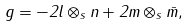Convert formula to latex. <formula><loc_0><loc_0><loc_500><loc_500>g = - 2 l \otimes _ { s } n + 2 m \otimes _ { s } \bar { m } ,</formula> 